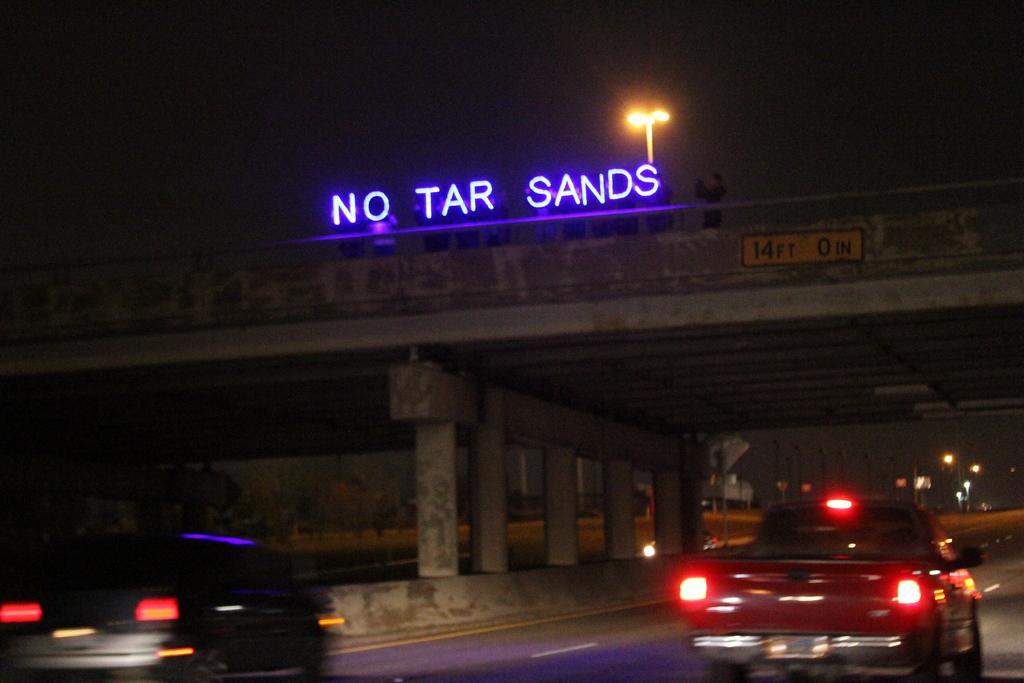In one or two sentences, can you explain what this image depicts? In the center of the image there is a bridge with text on it. There are people standing on it. At the bottom of the image there is road on which there are vehicles. In the background of the image there are light poles. At the top of the image there is sky. 